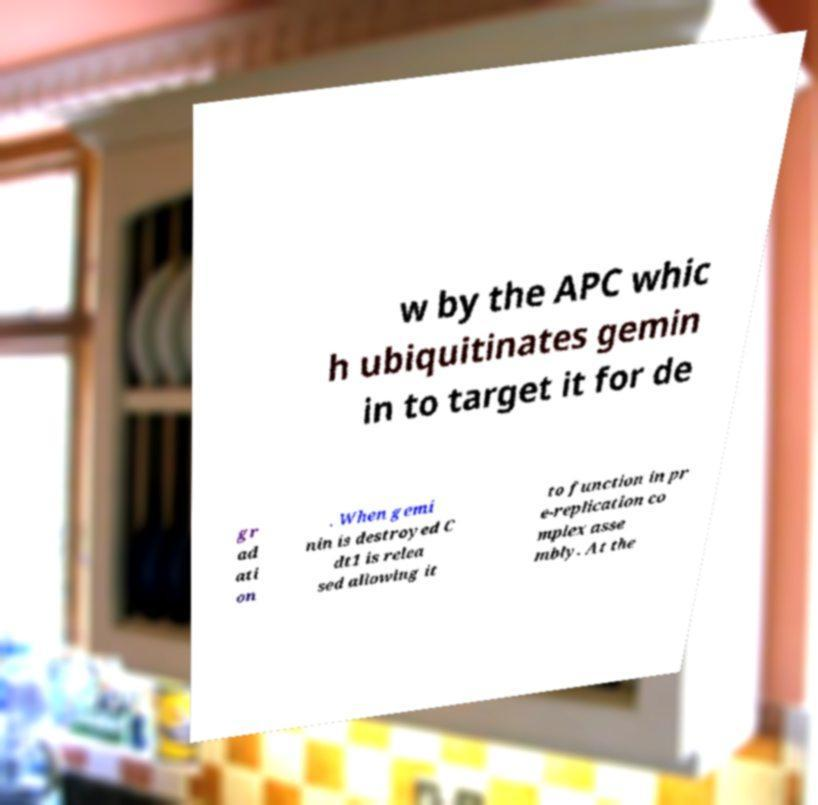There's text embedded in this image that I need extracted. Can you transcribe it verbatim? w by the APC whic h ubiquitinates gemin in to target it for de gr ad ati on . When gemi nin is destroyed C dt1 is relea sed allowing it to function in pr e-replication co mplex asse mbly. At the 